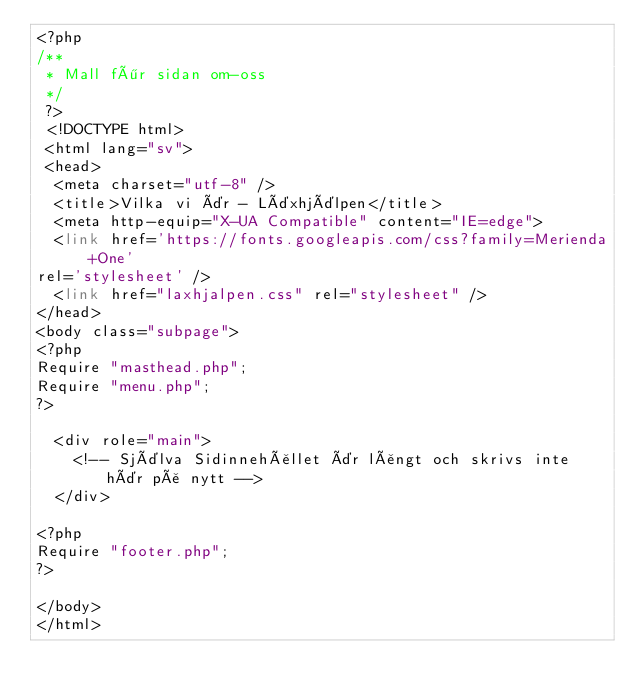Convert code to text. <code><loc_0><loc_0><loc_500><loc_500><_PHP_><?php
/**
 * Mall för sidan om-oss
 */
 ?>
 <!DOCTYPE html>
 <html lang="sv">
 <head>
	<meta charset="utf-8" />
	<title>Vilka vi är - Läxhjälpen</title>
	<meta http-equip="X-UA Compatible" content="IE=edge">
	<link href='https://fonts.googleapis.com/css?family=Merienda+One'
rel='stylesheet' />
	<link href="laxhjalpen.css" rel="stylesheet" />
</head>
<body class="subpage">
<?php
Require "masthead.php";
Require "menu.php";
?>

	<div role="main">
		<!-- Själva Sidinnehållet är långt och skrivs inte här på nytt -->
	</div>

<?php
Require "footer.php";
?>

</body>
</html></code> 